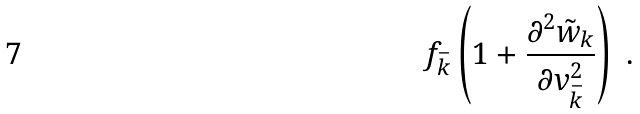<formula> <loc_0><loc_0><loc_500><loc_500>f _ { \bar { k } } \left ( 1 + \frac { \partial ^ { 2 } \tilde { w } _ { k } } { \partial v _ { \bar { k } } ^ { 2 } } \right ) \ .</formula> 